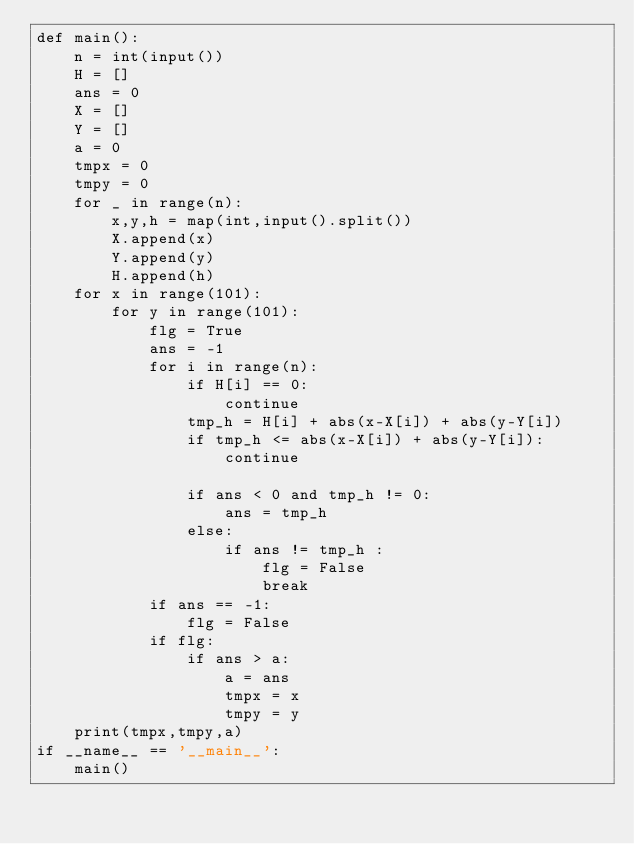<code> <loc_0><loc_0><loc_500><loc_500><_Python_>def main():
    n = int(input())
    H = []
    ans = 0
    X = []
    Y = []
    a = 0
    tmpx = 0
    tmpy = 0
    for _ in range(n):
        x,y,h = map(int,input().split())
        X.append(x)
        Y.append(y)
        H.append(h)
    for x in range(101):
        for y in range(101):
            flg = True
            ans = -1
            for i in range(n):
                if H[i] == 0:
                    continue
                tmp_h = H[i] + abs(x-X[i]) + abs(y-Y[i])
                if tmp_h <= abs(x-X[i]) + abs(y-Y[i]):
                    continue

                if ans < 0 and tmp_h != 0:
                    ans = tmp_h
                else:
                    if ans != tmp_h :
                        flg = False
                        break
            if ans == -1:
                flg = False
            if flg:
                if ans > a:
                    a = ans
                    tmpx = x
                    tmpy = y
    print(tmpx,tmpy,a)
if __name__ == '__main__':
    main()
</code> 